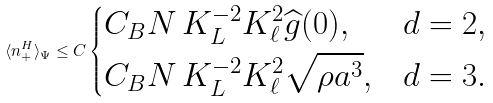<formula> <loc_0><loc_0><loc_500><loc_500>\langle n _ { + } ^ { H } \rangle _ { \Psi } \leq C \begin{dcases} C _ { B } N \, K _ { L } ^ { - 2 } K _ { \ell } ^ { 2 } \widehat { g } ( 0 ) , & d = 2 , \\ C _ { B } N \, K _ { L } ^ { - 2 } K _ { \ell } ^ { 2 } \sqrt { \rho a ^ { 3 } } , & d = 3 . \end{dcases}</formula> 